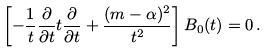<formula> <loc_0><loc_0><loc_500><loc_500>\left [ - \frac { 1 } { t } \frac { \partial } { \partial t } t \frac { \partial } { \partial t } + \frac { ( m - \alpha ) ^ { 2 } } { t ^ { 2 } } \right ] B _ { 0 } ( t ) = 0 \, .</formula> 